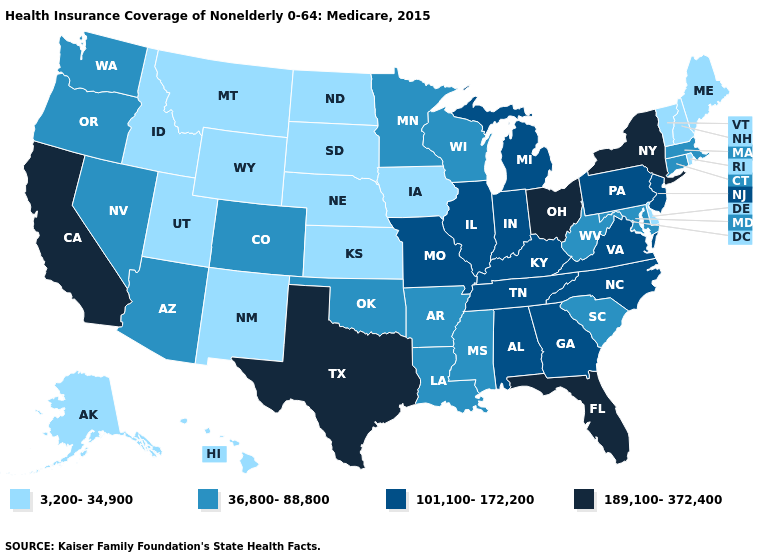Name the states that have a value in the range 36,800-88,800?
Concise answer only. Arizona, Arkansas, Colorado, Connecticut, Louisiana, Maryland, Massachusetts, Minnesota, Mississippi, Nevada, Oklahoma, Oregon, South Carolina, Washington, West Virginia, Wisconsin. Name the states that have a value in the range 3,200-34,900?
Keep it brief. Alaska, Delaware, Hawaii, Idaho, Iowa, Kansas, Maine, Montana, Nebraska, New Hampshire, New Mexico, North Dakota, Rhode Island, South Dakota, Utah, Vermont, Wyoming. What is the highest value in the West ?
Short answer required. 189,100-372,400. What is the value of Nevada?
Quick response, please. 36,800-88,800. Among the states that border Nebraska , does Kansas have the lowest value?
Give a very brief answer. Yes. What is the highest value in the USA?
Concise answer only. 189,100-372,400. What is the value of Kentucky?
Give a very brief answer. 101,100-172,200. Which states have the lowest value in the USA?
Answer briefly. Alaska, Delaware, Hawaii, Idaho, Iowa, Kansas, Maine, Montana, Nebraska, New Hampshire, New Mexico, North Dakota, Rhode Island, South Dakota, Utah, Vermont, Wyoming. What is the value of Idaho?
Be succinct. 3,200-34,900. Does Rhode Island have the lowest value in the USA?
Concise answer only. Yes. What is the value of New Hampshire?
Quick response, please. 3,200-34,900. What is the value of Arkansas?
Concise answer only. 36,800-88,800. Is the legend a continuous bar?
Concise answer only. No. What is the value of Virginia?
Be succinct. 101,100-172,200. Among the states that border Kentucky , which have the lowest value?
Give a very brief answer. West Virginia. 